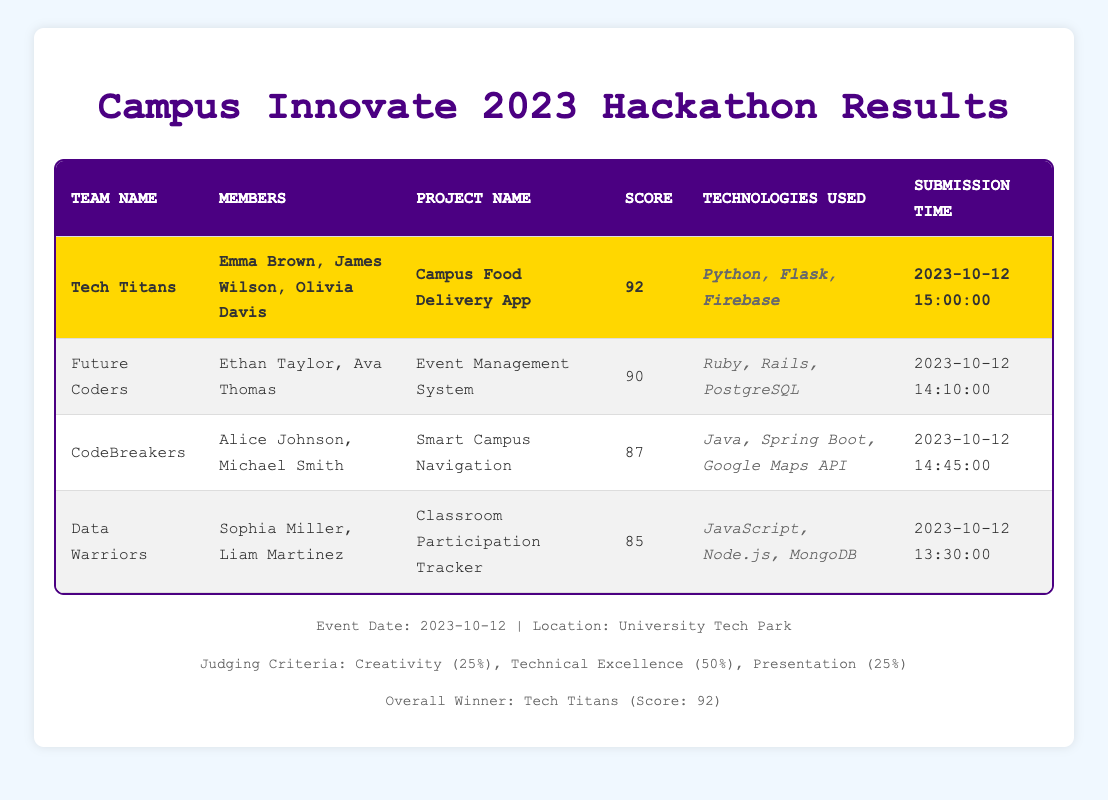What is the submission time of the project from the CodeBreakers team? The submission time for the CodeBreakers team is listed in the table under the "Submission Time" column. Referring to the row for CodeBreakers, the submission time is 2023-10-12 14:45:00.
Answer: 2023-10-12 14:45:00 Which team used Ruby in their project? The technologies used by each team are listed in the "Technologies Used" column. Scanning through the rows, the Future Coders team is the only one that lists Ruby as part of their technologies used.
Answer: Future Coders What is the average score of all participating teams? To find the average score, we need to sum the scores of all teams (92 + 90 + 87 + 85 = 354) and then divide by the number of teams (4). This gives us an average score of 354 divided by 4, which is 88.5.
Answer: 88.5 Did the Data Warriors score higher than the CodeBreakers? We first look at the scores of both teams: Data Warriors have a score of 85 and CodeBreakers have a score of 87. Since 85 is less than 87, the Data Warriors did not score higher than the CodeBreakers.
Answer: No Which team had the highest score, and what was that score? The overall winner is highlighted in the table, showing the team name and their score. Tech Titans is listed as the overall winner with a score of 92.
Answer: Tech Titans, 92 How many members are in the Tech Titans team? The number of members for each team is found in the "Members" column. The Tech Titans team lists three members: Emma Brown, James Wilson, and Olivia Davis. Therefore, Tech Titans has three members.
Answer: 3 What is the total score of teams that used Java? We check each team's technologies used and the corresponding scores. CodeBreakers uses Java with a score of 87, and Data Warriors also use Java with a score of 85. We then sum these scores: 87 + 85 = 172.
Answer: 172 Is there a team that scored exactly 90 points? We inspect the scores in the table and find that the Future Coders scored 90 points. Since there is at least one team with a score of exactly 90, the answer is yes.
Answer: Yes What time did the last team to submit their project submit? The submission times show when each team submitted their project. The last recorded time in the table is 2023-10-12 15:00:00 from the Tech Titans team, indicating that they were the last to submit.
Answer: 2023-10-12 15:00:00 